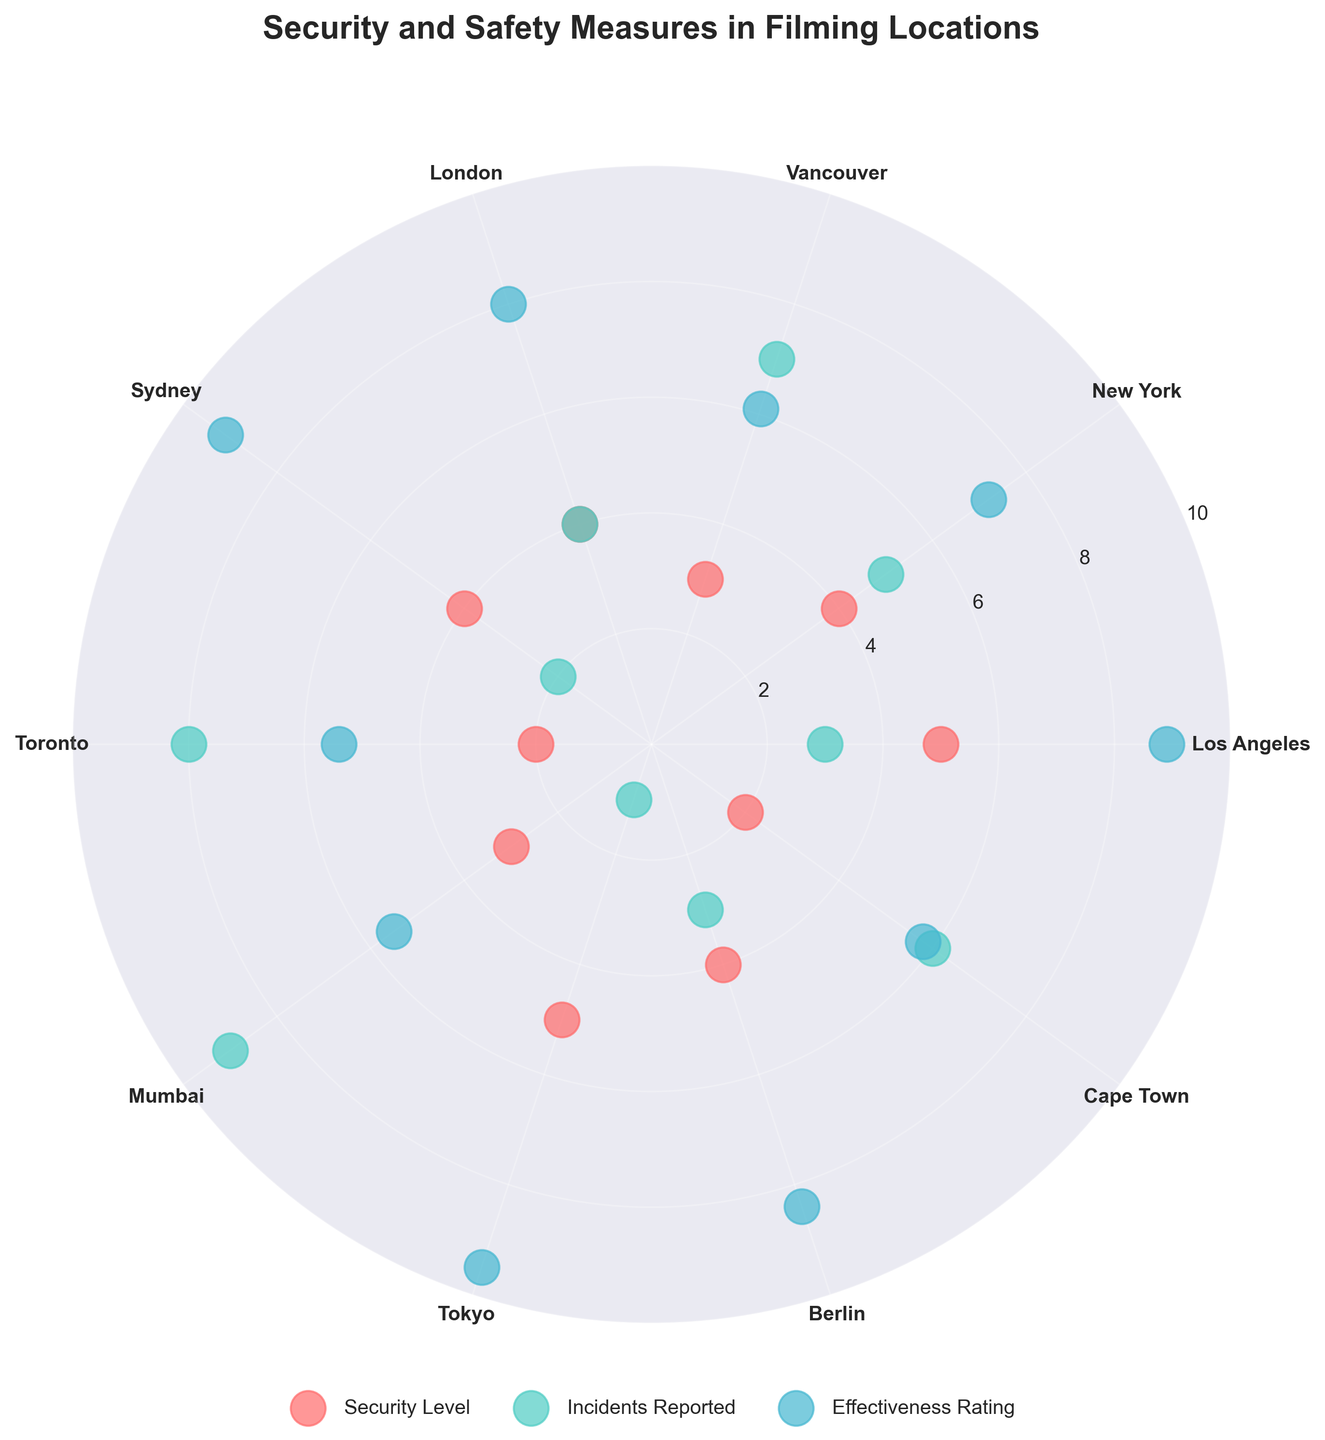What locations have a security level greater than 4? By looking at the positions of the "Security Level" points on the chart, we can identify the location names associated with values greater than 4.
Answer: Los Angeles, Tokyo What is the title of the polar scatter chart? The title is usually located at the top of the chart and clearly states the subject of the figure.
Answer: Security and Safety Measures in Filming Locations Which location has the highest effectiveness rating? Check the "Effectiveness Rating" points and look for the one with the highest value, which can be found by seeing which point is furthest out from the center.
Answer: Tokyo What is the average incidents reported across all locations? Sum the "Incidents Reported" values for all locations and divide by the number of data points (10). This is calculated as: (3+5+7+4+2+8+9+1+3+6) / 10 = 48 / 10 = 4.8
Answer: 4.8 What is the relationship between security level and effectiveness rating in Tokyo? Find the points labeled "Tokyo" and compare the "Security Level" and "Effectiveness Rating" values.
Answer: Higher security level and highest effectiveness rating Which location reported the least number of incidents? Check the "Incidents Reported" points and identify the one with the smallest value.
Answer: Tokyo On average, do locations with a higher security level have fewer incidents reported? For locations with a security level of 4 or 5, compute the average number of incidents (Los Angeles:3, New York:5, London:4, Sydney:2, Berlin:3, Tokyo:1) => (3+5+4+2+3+1) / 6 = 18 / 6 = 3. For levels lower than 4 (Vancouver, Toronto, Mumbai, Cape Town) => (7+8+9+6) / 4 = 30 / 4 = 7.5. Compare these averages.
Answer: Yes What color represents the incidents reported in the chart? Identify the color used to plot "Incidents Reported" by examining the legend on the chart.
Answer: Teal Green Is there a location with a security level of 2 and more than 5 incidents reported? Check for locations with a "Security Level" of 2 and assess if their "Incidents Reported" are higher than 5.
Answer: Toronto, Cape Town Which location has the highest combination of security level and effectiveness rating? Sum the values of "Security Level" and "Effectiveness Rating" for each location and identify the one with the highest combined total. Tokyo: 5 + 9.5 = 14.5, next highest is Sydney: 4 + 9.1 = 13.1
Answer: Tokyo What pattern do you observe between security level and incidents reported in London? Find London's points and observe trends or patterns between "Security Level" and "Incidents Reported".
Answer: Moderate security level with moderate number of incidents 